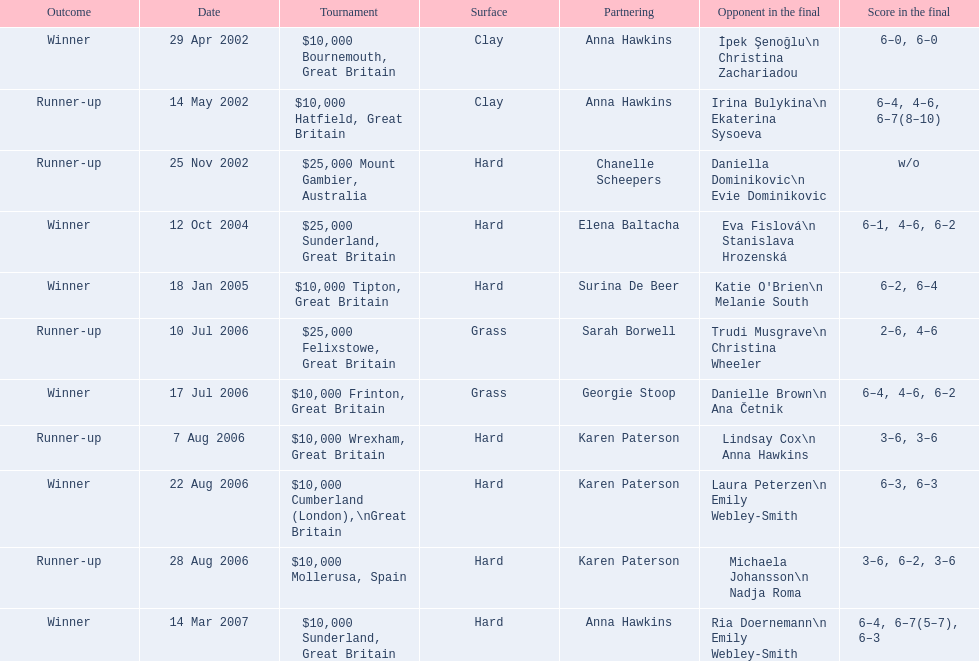In how many competitions has jane o'donoghue participated? 11. 